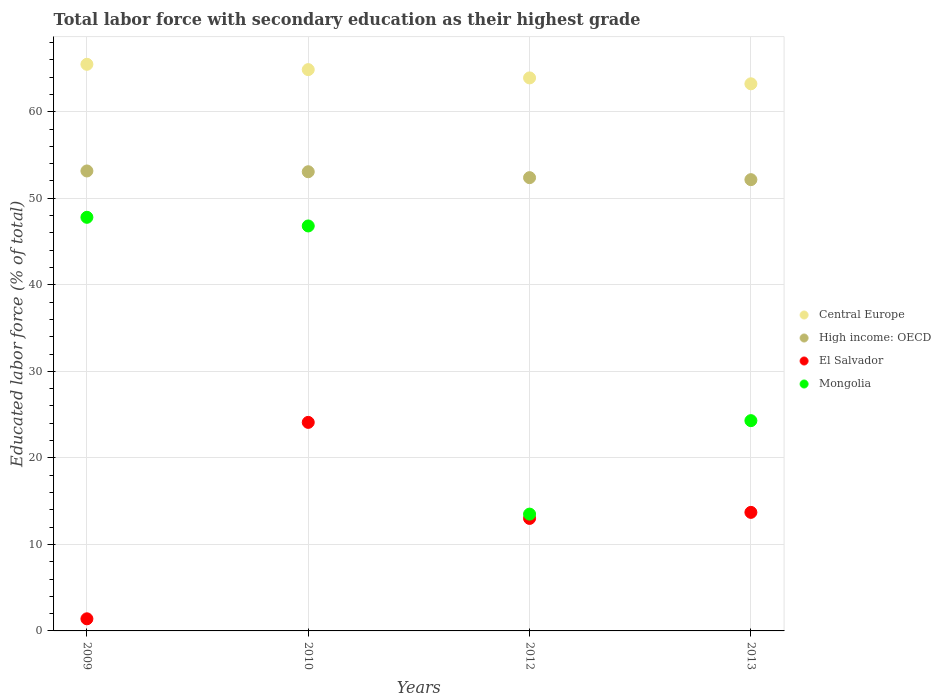What is the percentage of total labor force with primary education in Mongolia in 2013?
Provide a short and direct response. 24.3. Across all years, what is the maximum percentage of total labor force with primary education in Mongolia?
Your answer should be very brief. 47.8. Across all years, what is the minimum percentage of total labor force with primary education in High income: OECD?
Offer a very short reply. 52.15. In which year was the percentage of total labor force with primary education in Central Europe maximum?
Make the answer very short. 2009. What is the total percentage of total labor force with primary education in High income: OECD in the graph?
Your response must be concise. 210.75. What is the difference between the percentage of total labor force with primary education in Central Europe in 2012 and that in 2013?
Provide a short and direct response. 0.68. What is the difference between the percentage of total labor force with primary education in Mongolia in 2013 and the percentage of total labor force with primary education in El Salvador in 2012?
Your answer should be very brief. 11.3. What is the average percentage of total labor force with primary education in Mongolia per year?
Keep it short and to the point. 33.1. In the year 2013, what is the difference between the percentage of total labor force with primary education in El Salvador and percentage of total labor force with primary education in Mongolia?
Make the answer very short. -10.6. In how many years, is the percentage of total labor force with primary education in High income: OECD greater than 18 %?
Offer a very short reply. 4. What is the ratio of the percentage of total labor force with primary education in El Salvador in 2009 to that in 2013?
Offer a very short reply. 0.1. Is the percentage of total labor force with primary education in El Salvador in 2009 less than that in 2010?
Give a very brief answer. Yes. Is the difference between the percentage of total labor force with primary education in El Salvador in 2012 and 2013 greater than the difference between the percentage of total labor force with primary education in Mongolia in 2012 and 2013?
Provide a succinct answer. Yes. What is the difference between the highest and the second highest percentage of total labor force with primary education in High income: OECD?
Make the answer very short. 0.09. What is the difference between the highest and the lowest percentage of total labor force with primary education in Mongolia?
Provide a short and direct response. 34.3. Is it the case that in every year, the sum of the percentage of total labor force with primary education in Mongolia and percentage of total labor force with primary education in Central Europe  is greater than the sum of percentage of total labor force with primary education in El Salvador and percentage of total labor force with primary education in High income: OECD?
Give a very brief answer. Yes. Is the percentage of total labor force with primary education in High income: OECD strictly less than the percentage of total labor force with primary education in El Salvador over the years?
Your answer should be compact. No. How many dotlines are there?
Your response must be concise. 4. What is the difference between two consecutive major ticks on the Y-axis?
Give a very brief answer. 10. Are the values on the major ticks of Y-axis written in scientific E-notation?
Your response must be concise. No. Where does the legend appear in the graph?
Your response must be concise. Center right. What is the title of the graph?
Ensure brevity in your answer.  Total labor force with secondary education as their highest grade. Does "Eritrea" appear as one of the legend labels in the graph?
Offer a very short reply. No. What is the label or title of the X-axis?
Provide a succinct answer. Years. What is the label or title of the Y-axis?
Your response must be concise. Educated labor force (% of total). What is the Educated labor force (% of total) in Central Europe in 2009?
Make the answer very short. 65.48. What is the Educated labor force (% of total) in High income: OECD in 2009?
Provide a succinct answer. 53.16. What is the Educated labor force (% of total) of El Salvador in 2009?
Your response must be concise. 1.4. What is the Educated labor force (% of total) in Mongolia in 2009?
Ensure brevity in your answer.  47.8. What is the Educated labor force (% of total) in Central Europe in 2010?
Give a very brief answer. 64.87. What is the Educated labor force (% of total) in High income: OECD in 2010?
Make the answer very short. 53.07. What is the Educated labor force (% of total) in El Salvador in 2010?
Provide a short and direct response. 24.1. What is the Educated labor force (% of total) of Mongolia in 2010?
Offer a very short reply. 46.8. What is the Educated labor force (% of total) of Central Europe in 2012?
Provide a short and direct response. 63.91. What is the Educated labor force (% of total) in High income: OECD in 2012?
Keep it short and to the point. 52.38. What is the Educated labor force (% of total) of Central Europe in 2013?
Provide a short and direct response. 63.23. What is the Educated labor force (% of total) of High income: OECD in 2013?
Offer a terse response. 52.15. What is the Educated labor force (% of total) of El Salvador in 2013?
Offer a terse response. 13.7. What is the Educated labor force (% of total) of Mongolia in 2013?
Keep it short and to the point. 24.3. Across all years, what is the maximum Educated labor force (% of total) of Central Europe?
Offer a terse response. 65.48. Across all years, what is the maximum Educated labor force (% of total) of High income: OECD?
Keep it short and to the point. 53.16. Across all years, what is the maximum Educated labor force (% of total) of El Salvador?
Keep it short and to the point. 24.1. Across all years, what is the maximum Educated labor force (% of total) in Mongolia?
Keep it short and to the point. 47.8. Across all years, what is the minimum Educated labor force (% of total) of Central Europe?
Offer a very short reply. 63.23. Across all years, what is the minimum Educated labor force (% of total) in High income: OECD?
Offer a very short reply. 52.15. Across all years, what is the minimum Educated labor force (% of total) in El Salvador?
Provide a short and direct response. 1.4. What is the total Educated labor force (% of total) in Central Europe in the graph?
Your response must be concise. 257.48. What is the total Educated labor force (% of total) of High income: OECD in the graph?
Make the answer very short. 210.75. What is the total Educated labor force (% of total) of El Salvador in the graph?
Keep it short and to the point. 52.2. What is the total Educated labor force (% of total) of Mongolia in the graph?
Your response must be concise. 132.4. What is the difference between the Educated labor force (% of total) in Central Europe in 2009 and that in 2010?
Offer a very short reply. 0.61. What is the difference between the Educated labor force (% of total) in High income: OECD in 2009 and that in 2010?
Make the answer very short. 0.09. What is the difference between the Educated labor force (% of total) in El Salvador in 2009 and that in 2010?
Provide a short and direct response. -22.7. What is the difference between the Educated labor force (% of total) of Mongolia in 2009 and that in 2010?
Make the answer very short. 1. What is the difference between the Educated labor force (% of total) of Central Europe in 2009 and that in 2012?
Give a very brief answer. 1.57. What is the difference between the Educated labor force (% of total) of High income: OECD in 2009 and that in 2012?
Make the answer very short. 0.77. What is the difference between the Educated labor force (% of total) of El Salvador in 2009 and that in 2012?
Provide a short and direct response. -11.6. What is the difference between the Educated labor force (% of total) of Mongolia in 2009 and that in 2012?
Provide a short and direct response. 34.3. What is the difference between the Educated labor force (% of total) in Central Europe in 2009 and that in 2013?
Your response must be concise. 2.25. What is the difference between the Educated labor force (% of total) of High income: OECD in 2009 and that in 2013?
Make the answer very short. 1. What is the difference between the Educated labor force (% of total) of Mongolia in 2009 and that in 2013?
Your answer should be very brief. 23.5. What is the difference between the Educated labor force (% of total) of Central Europe in 2010 and that in 2012?
Provide a succinct answer. 0.96. What is the difference between the Educated labor force (% of total) in High income: OECD in 2010 and that in 2012?
Your answer should be very brief. 0.68. What is the difference between the Educated labor force (% of total) in Mongolia in 2010 and that in 2012?
Offer a terse response. 33.3. What is the difference between the Educated labor force (% of total) in Central Europe in 2010 and that in 2013?
Offer a very short reply. 1.64. What is the difference between the Educated labor force (% of total) in High income: OECD in 2010 and that in 2013?
Ensure brevity in your answer.  0.91. What is the difference between the Educated labor force (% of total) of El Salvador in 2010 and that in 2013?
Keep it short and to the point. 10.4. What is the difference between the Educated labor force (% of total) of Central Europe in 2012 and that in 2013?
Your response must be concise. 0.68. What is the difference between the Educated labor force (% of total) of High income: OECD in 2012 and that in 2013?
Keep it short and to the point. 0.23. What is the difference between the Educated labor force (% of total) in El Salvador in 2012 and that in 2013?
Your answer should be compact. -0.7. What is the difference between the Educated labor force (% of total) in Central Europe in 2009 and the Educated labor force (% of total) in High income: OECD in 2010?
Make the answer very short. 12.42. What is the difference between the Educated labor force (% of total) in Central Europe in 2009 and the Educated labor force (% of total) in El Salvador in 2010?
Make the answer very short. 41.38. What is the difference between the Educated labor force (% of total) in Central Europe in 2009 and the Educated labor force (% of total) in Mongolia in 2010?
Your response must be concise. 18.68. What is the difference between the Educated labor force (% of total) of High income: OECD in 2009 and the Educated labor force (% of total) of El Salvador in 2010?
Keep it short and to the point. 29.06. What is the difference between the Educated labor force (% of total) in High income: OECD in 2009 and the Educated labor force (% of total) in Mongolia in 2010?
Give a very brief answer. 6.36. What is the difference between the Educated labor force (% of total) in El Salvador in 2009 and the Educated labor force (% of total) in Mongolia in 2010?
Your response must be concise. -45.4. What is the difference between the Educated labor force (% of total) of Central Europe in 2009 and the Educated labor force (% of total) of High income: OECD in 2012?
Give a very brief answer. 13.1. What is the difference between the Educated labor force (% of total) in Central Europe in 2009 and the Educated labor force (% of total) in El Salvador in 2012?
Provide a short and direct response. 52.48. What is the difference between the Educated labor force (% of total) in Central Europe in 2009 and the Educated labor force (% of total) in Mongolia in 2012?
Your response must be concise. 51.98. What is the difference between the Educated labor force (% of total) of High income: OECD in 2009 and the Educated labor force (% of total) of El Salvador in 2012?
Keep it short and to the point. 40.16. What is the difference between the Educated labor force (% of total) in High income: OECD in 2009 and the Educated labor force (% of total) in Mongolia in 2012?
Ensure brevity in your answer.  39.66. What is the difference between the Educated labor force (% of total) in Central Europe in 2009 and the Educated labor force (% of total) in High income: OECD in 2013?
Ensure brevity in your answer.  13.33. What is the difference between the Educated labor force (% of total) in Central Europe in 2009 and the Educated labor force (% of total) in El Salvador in 2013?
Provide a short and direct response. 51.78. What is the difference between the Educated labor force (% of total) in Central Europe in 2009 and the Educated labor force (% of total) in Mongolia in 2013?
Your answer should be very brief. 41.18. What is the difference between the Educated labor force (% of total) of High income: OECD in 2009 and the Educated labor force (% of total) of El Salvador in 2013?
Keep it short and to the point. 39.46. What is the difference between the Educated labor force (% of total) of High income: OECD in 2009 and the Educated labor force (% of total) of Mongolia in 2013?
Offer a terse response. 28.86. What is the difference between the Educated labor force (% of total) of El Salvador in 2009 and the Educated labor force (% of total) of Mongolia in 2013?
Your answer should be very brief. -22.9. What is the difference between the Educated labor force (% of total) in Central Europe in 2010 and the Educated labor force (% of total) in High income: OECD in 2012?
Your answer should be compact. 12.48. What is the difference between the Educated labor force (% of total) of Central Europe in 2010 and the Educated labor force (% of total) of El Salvador in 2012?
Keep it short and to the point. 51.87. What is the difference between the Educated labor force (% of total) in Central Europe in 2010 and the Educated labor force (% of total) in Mongolia in 2012?
Make the answer very short. 51.37. What is the difference between the Educated labor force (% of total) in High income: OECD in 2010 and the Educated labor force (% of total) in El Salvador in 2012?
Your answer should be compact. 40.07. What is the difference between the Educated labor force (% of total) in High income: OECD in 2010 and the Educated labor force (% of total) in Mongolia in 2012?
Your response must be concise. 39.57. What is the difference between the Educated labor force (% of total) in El Salvador in 2010 and the Educated labor force (% of total) in Mongolia in 2012?
Give a very brief answer. 10.6. What is the difference between the Educated labor force (% of total) in Central Europe in 2010 and the Educated labor force (% of total) in High income: OECD in 2013?
Offer a terse response. 12.72. What is the difference between the Educated labor force (% of total) in Central Europe in 2010 and the Educated labor force (% of total) in El Salvador in 2013?
Give a very brief answer. 51.17. What is the difference between the Educated labor force (% of total) in Central Europe in 2010 and the Educated labor force (% of total) in Mongolia in 2013?
Your response must be concise. 40.57. What is the difference between the Educated labor force (% of total) of High income: OECD in 2010 and the Educated labor force (% of total) of El Salvador in 2013?
Make the answer very short. 39.37. What is the difference between the Educated labor force (% of total) in High income: OECD in 2010 and the Educated labor force (% of total) in Mongolia in 2013?
Keep it short and to the point. 28.77. What is the difference between the Educated labor force (% of total) in El Salvador in 2010 and the Educated labor force (% of total) in Mongolia in 2013?
Your answer should be very brief. -0.2. What is the difference between the Educated labor force (% of total) of Central Europe in 2012 and the Educated labor force (% of total) of High income: OECD in 2013?
Ensure brevity in your answer.  11.76. What is the difference between the Educated labor force (% of total) of Central Europe in 2012 and the Educated labor force (% of total) of El Salvador in 2013?
Offer a very short reply. 50.21. What is the difference between the Educated labor force (% of total) in Central Europe in 2012 and the Educated labor force (% of total) in Mongolia in 2013?
Your answer should be very brief. 39.61. What is the difference between the Educated labor force (% of total) in High income: OECD in 2012 and the Educated labor force (% of total) in El Salvador in 2013?
Give a very brief answer. 38.68. What is the difference between the Educated labor force (% of total) in High income: OECD in 2012 and the Educated labor force (% of total) in Mongolia in 2013?
Ensure brevity in your answer.  28.08. What is the difference between the Educated labor force (% of total) of El Salvador in 2012 and the Educated labor force (% of total) of Mongolia in 2013?
Provide a succinct answer. -11.3. What is the average Educated labor force (% of total) of Central Europe per year?
Provide a succinct answer. 64.37. What is the average Educated labor force (% of total) in High income: OECD per year?
Your response must be concise. 52.69. What is the average Educated labor force (% of total) in El Salvador per year?
Provide a succinct answer. 13.05. What is the average Educated labor force (% of total) in Mongolia per year?
Make the answer very short. 33.1. In the year 2009, what is the difference between the Educated labor force (% of total) of Central Europe and Educated labor force (% of total) of High income: OECD?
Your answer should be compact. 12.33. In the year 2009, what is the difference between the Educated labor force (% of total) of Central Europe and Educated labor force (% of total) of El Salvador?
Provide a short and direct response. 64.08. In the year 2009, what is the difference between the Educated labor force (% of total) of Central Europe and Educated labor force (% of total) of Mongolia?
Offer a terse response. 17.68. In the year 2009, what is the difference between the Educated labor force (% of total) of High income: OECD and Educated labor force (% of total) of El Salvador?
Offer a very short reply. 51.76. In the year 2009, what is the difference between the Educated labor force (% of total) of High income: OECD and Educated labor force (% of total) of Mongolia?
Offer a terse response. 5.36. In the year 2009, what is the difference between the Educated labor force (% of total) of El Salvador and Educated labor force (% of total) of Mongolia?
Offer a terse response. -46.4. In the year 2010, what is the difference between the Educated labor force (% of total) in Central Europe and Educated labor force (% of total) in High income: OECD?
Give a very brief answer. 11.8. In the year 2010, what is the difference between the Educated labor force (% of total) of Central Europe and Educated labor force (% of total) of El Salvador?
Your response must be concise. 40.77. In the year 2010, what is the difference between the Educated labor force (% of total) in Central Europe and Educated labor force (% of total) in Mongolia?
Ensure brevity in your answer.  18.07. In the year 2010, what is the difference between the Educated labor force (% of total) of High income: OECD and Educated labor force (% of total) of El Salvador?
Make the answer very short. 28.97. In the year 2010, what is the difference between the Educated labor force (% of total) in High income: OECD and Educated labor force (% of total) in Mongolia?
Make the answer very short. 6.27. In the year 2010, what is the difference between the Educated labor force (% of total) in El Salvador and Educated labor force (% of total) in Mongolia?
Ensure brevity in your answer.  -22.7. In the year 2012, what is the difference between the Educated labor force (% of total) in Central Europe and Educated labor force (% of total) in High income: OECD?
Ensure brevity in your answer.  11.53. In the year 2012, what is the difference between the Educated labor force (% of total) in Central Europe and Educated labor force (% of total) in El Salvador?
Offer a very short reply. 50.91. In the year 2012, what is the difference between the Educated labor force (% of total) of Central Europe and Educated labor force (% of total) of Mongolia?
Give a very brief answer. 50.41. In the year 2012, what is the difference between the Educated labor force (% of total) in High income: OECD and Educated labor force (% of total) in El Salvador?
Ensure brevity in your answer.  39.38. In the year 2012, what is the difference between the Educated labor force (% of total) of High income: OECD and Educated labor force (% of total) of Mongolia?
Your answer should be compact. 38.88. In the year 2013, what is the difference between the Educated labor force (% of total) of Central Europe and Educated labor force (% of total) of High income: OECD?
Offer a very short reply. 11.08. In the year 2013, what is the difference between the Educated labor force (% of total) in Central Europe and Educated labor force (% of total) in El Salvador?
Your response must be concise. 49.53. In the year 2013, what is the difference between the Educated labor force (% of total) in Central Europe and Educated labor force (% of total) in Mongolia?
Ensure brevity in your answer.  38.93. In the year 2013, what is the difference between the Educated labor force (% of total) in High income: OECD and Educated labor force (% of total) in El Salvador?
Provide a short and direct response. 38.45. In the year 2013, what is the difference between the Educated labor force (% of total) in High income: OECD and Educated labor force (% of total) in Mongolia?
Give a very brief answer. 27.85. In the year 2013, what is the difference between the Educated labor force (% of total) in El Salvador and Educated labor force (% of total) in Mongolia?
Offer a terse response. -10.6. What is the ratio of the Educated labor force (% of total) of Central Europe in 2009 to that in 2010?
Your answer should be very brief. 1.01. What is the ratio of the Educated labor force (% of total) in High income: OECD in 2009 to that in 2010?
Make the answer very short. 1. What is the ratio of the Educated labor force (% of total) in El Salvador in 2009 to that in 2010?
Provide a succinct answer. 0.06. What is the ratio of the Educated labor force (% of total) of Mongolia in 2009 to that in 2010?
Your answer should be compact. 1.02. What is the ratio of the Educated labor force (% of total) in Central Europe in 2009 to that in 2012?
Your response must be concise. 1.02. What is the ratio of the Educated labor force (% of total) in High income: OECD in 2009 to that in 2012?
Give a very brief answer. 1.01. What is the ratio of the Educated labor force (% of total) in El Salvador in 2009 to that in 2012?
Provide a succinct answer. 0.11. What is the ratio of the Educated labor force (% of total) in Mongolia in 2009 to that in 2012?
Your answer should be very brief. 3.54. What is the ratio of the Educated labor force (% of total) in Central Europe in 2009 to that in 2013?
Ensure brevity in your answer.  1.04. What is the ratio of the Educated labor force (% of total) of High income: OECD in 2009 to that in 2013?
Offer a terse response. 1.02. What is the ratio of the Educated labor force (% of total) in El Salvador in 2009 to that in 2013?
Provide a short and direct response. 0.1. What is the ratio of the Educated labor force (% of total) of Mongolia in 2009 to that in 2013?
Make the answer very short. 1.97. What is the ratio of the Educated labor force (% of total) in High income: OECD in 2010 to that in 2012?
Provide a succinct answer. 1.01. What is the ratio of the Educated labor force (% of total) of El Salvador in 2010 to that in 2012?
Offer a terse response. 1.85. What is the ratio of the Educated labor force (% of total) in Mongolia in 2010 to that in 2012?
Give a very brief answer. 3.47. What is the ratio of the Educated labor force (% of total) of Central Europe in 2010 to that in 2013?
Offer a very short reply. 1.03. What is the ratio of the Educated labor force (% of total) of High income: OECD in 2010 to that in 2013?
Offer a very short reply. 1.02. What is the ratio of the Educated labor force (% of total) of El Salvador in 2010 to that in 2013?
Offer a very short reply. 1.76. What is the ratio of the Educated labor force (% of total) of Mongolia in 2010 to that in 2013?
Offer a terse response. 1.93. What is the ratio of the Educated labor force (% of total) of Central Europe in 2012 to that in 2013?
Your answer should be very brief. 1.01. What is the ratio of the Educated labor force (% of total) in El Salvador in 2012 to that in 2013?
Your response must be concise. 0.95. What is the ratio of the Educated labor force (% of total) in Mongolia in 2012 to that in 2013?
Your response must be concise. 0.56. What is the difference between the highest and the second highest Educated labor force (% of total) in Central Europe?
Your answer should be compact. 0.61. What is the difference between the highest and the second highest Educated labor force (% of total) in High income: OECD?
Keep it short and to the point. 0.09. What is the difference between the highest and the second highest Educated labor force (% of total) of El Salvador?
Your answer should be compact. 10.4. What is the difference between the highest and the lowest Educated labor force (% of total) of Central Europe?
Ensure brevity in your answer.  2.25. What is the difference between the highest and the lowest Educated labor force (% of total) of El Salvador?
Provide a short and direct response. 22.7. What is the difference between the highest and the lowest Educated labor force (% of total) in Mongolia?
Offer a very short reply. 34.3. 